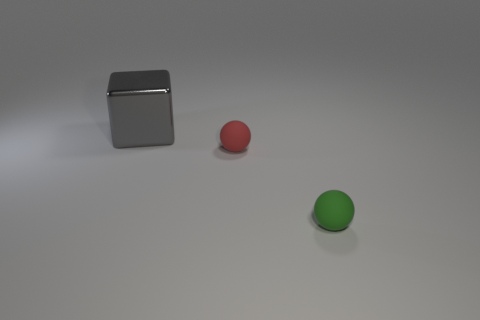Add 1 gray blocks. How many objects exist? 4 Subtract all balls. How many objects are left? 1 Add 3 gray metal cubes. How many gray metal cubes exist? 4 Subtract 0 brown cylinders. How many objects are left? 3 Subtract all gray cubes. Subtract all gray metallic cubes. How many objects are left? 1 Add 2 balls. How many balls are left? 4 